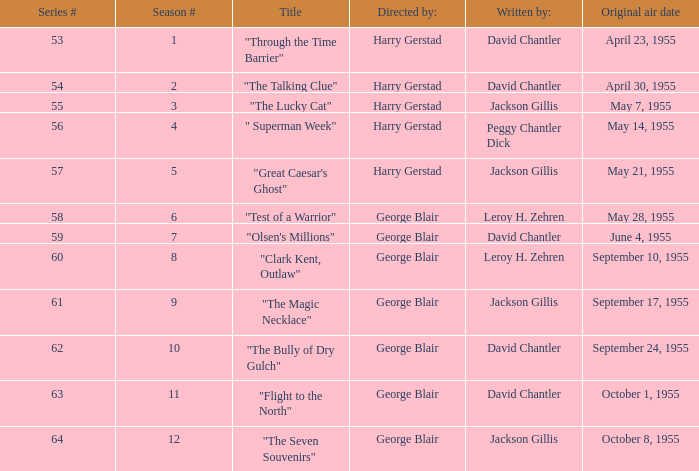What is the smallest number in a series? 53.0. Can you give me this table as a dict? {'header': ['Series #', 'Season #', 'Title', 'Directed by:', 'Written by:', 'Original air date'], 'rows': [['53', '1', '"Through the Time Barrier"', 'Harry Gerstad', 'David Chantler', 'April 23, 1955'], ['54', '2', '"The Talking Clue"', 'Harry Gerstad', 'David Chantler', 'April 30, 1955'], ['55', '3', '"The Lucky Cat"', 'Harry Gerstad', 'Jackson Gillis', 'May 7, 1955'], ['56', '4', '" Superman Week"', 'Harry Gerstad', 'Peggy Chantler Dick', 'May 14, 1955'], ['57', '5', '"Great Caesar\'s Ghost"', 'Harry Gerstad', 'Jackson Gillis', 'May 21, 1955'], ['58', '6', '"Test of a Warrior"', 'George Blair', 'Leroy H. Zehren', 'May 28, 1955'], ['59', '7', '"Olsen\'s Millions"', 'George Blair', 'David Chantler', 'June 4, 1955'], ['60', '8', '"Clark Kent, Outlaw"', 'George Blair', 'Leroy H. Zehren', 'September 10, 1955'], ['61', '9', '"The Magic Necklace"', 'George Blair', 'Jackson Gillis', 'September 17, 1955'], ['62', '10', '"The Bully of Dry Gulch"', 'George Blair', 'David Chantler', 'September 24, 1955'], ['63', '11', '"Flight to the North"', 'George Blair', 'David Chantler', 'October 1, 1955'], ['64', '12', '"The Seven Souvenirs"', 'George Blair', 'Jackson Gillis', 'October 8, 1955']]} 